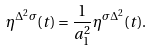Convert formula to latex. <formula><loc_0><loc_0><loc_500><loc_500>\eta ^ { \Delta ^ { 2 } \sigma } ( t ) = \frac { 1 } { a _ { 1 } ^ { 2 } } \eta ^ { \sigma \Delta ^ { 2 } } ( t ) .</formula> 